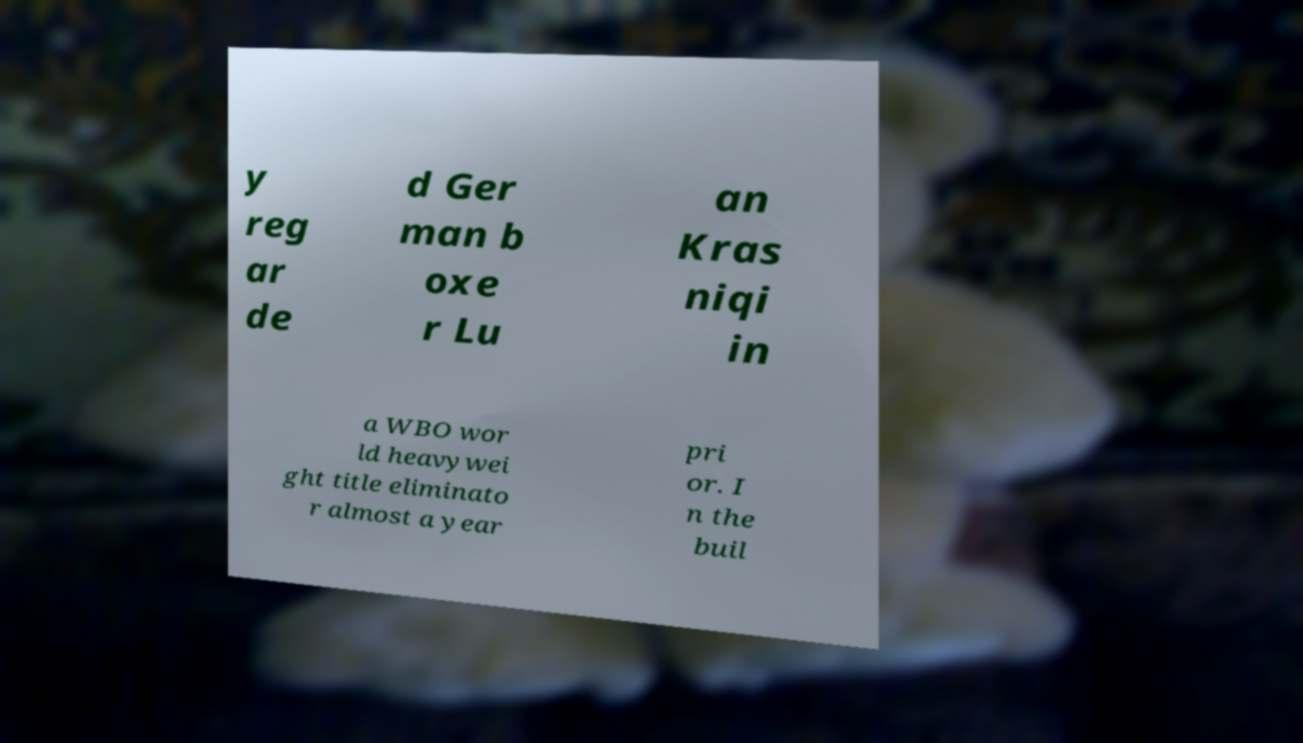Please identify and transcribe the text found in this image. y reg ar de d Ger man b oxe r Lu an Kras niqi in a WBO wor ld heavywei ght title eliminato r almost a year pri or. I n the buil 